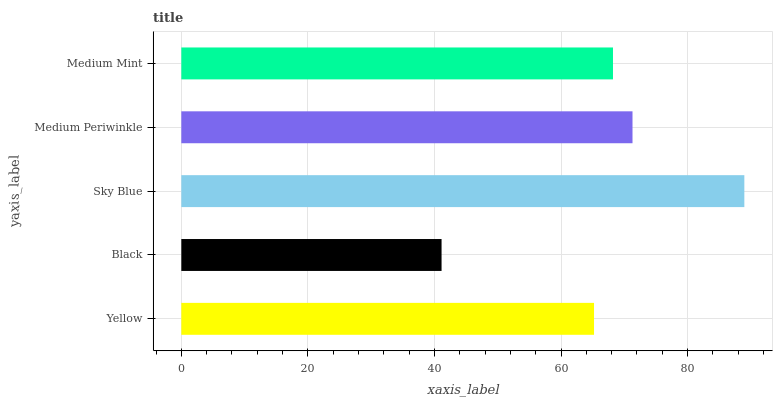Is Black the minimum?
Answer yes or no. Yes. Is Sky Blue the maximum?
Answer yes or no. Yes. Is Sky Blue the minimum?
Answer yes or no. No. Is Black the maximum?
Answer yes or no. No. Is Sky Blue greater than Black?
Answer yes or no. Yes. Is Black less than Sky Blue?
Answer yes or no. Yes. Is Black greater than Sky Blue?
Answer yes or no. No. Is Sky Blue less than Black?
Answer yes or no. No. Is Medium Mint the high median?
Answer yes or no. Yes. Is Medium Mint the low median?
Answer yes or no. Yes. Is Black the high median?
Answer yes or no. No. Is Yellow the low median?
Answer yes or no. No. 